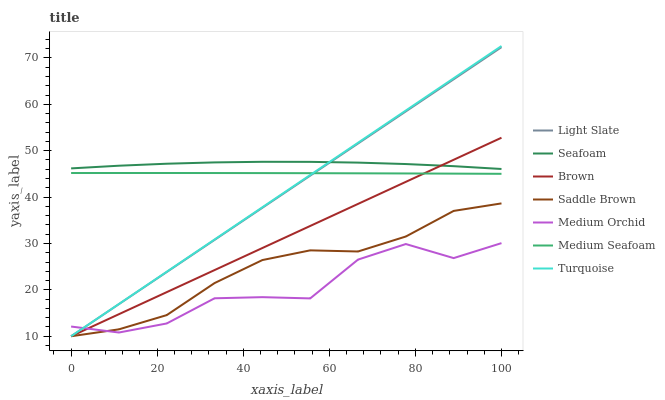Does Medium Orchid have the minimum area under the curve?
Answer yes or no. Yes. Does Turquoise have the minimum area under the curve?
Answer yes or no. No. Does Turquoise have the maximum area under the curve?
Answer yes or no. No. Is Medium Orchid the roughest?
Answer yes or no. Yes. Is Turquoise the smoothest?
Answer yes or no. No. Is Turquoise the roughest?
Answer yes or no. No. Does Medium Orchid have the lowest value?
Answer yes or no. No. Does Light Slate have the highest value?
Answer yes or no. No. Is Medium Seafoam less than Seafoam?
Answer yes or no. Yes. Is Seafoam greater than Medium Orchid?
Answer yes or no. Yes. Does Medium Seafoam intersect Seafoam?
Answer yes or no. No. 